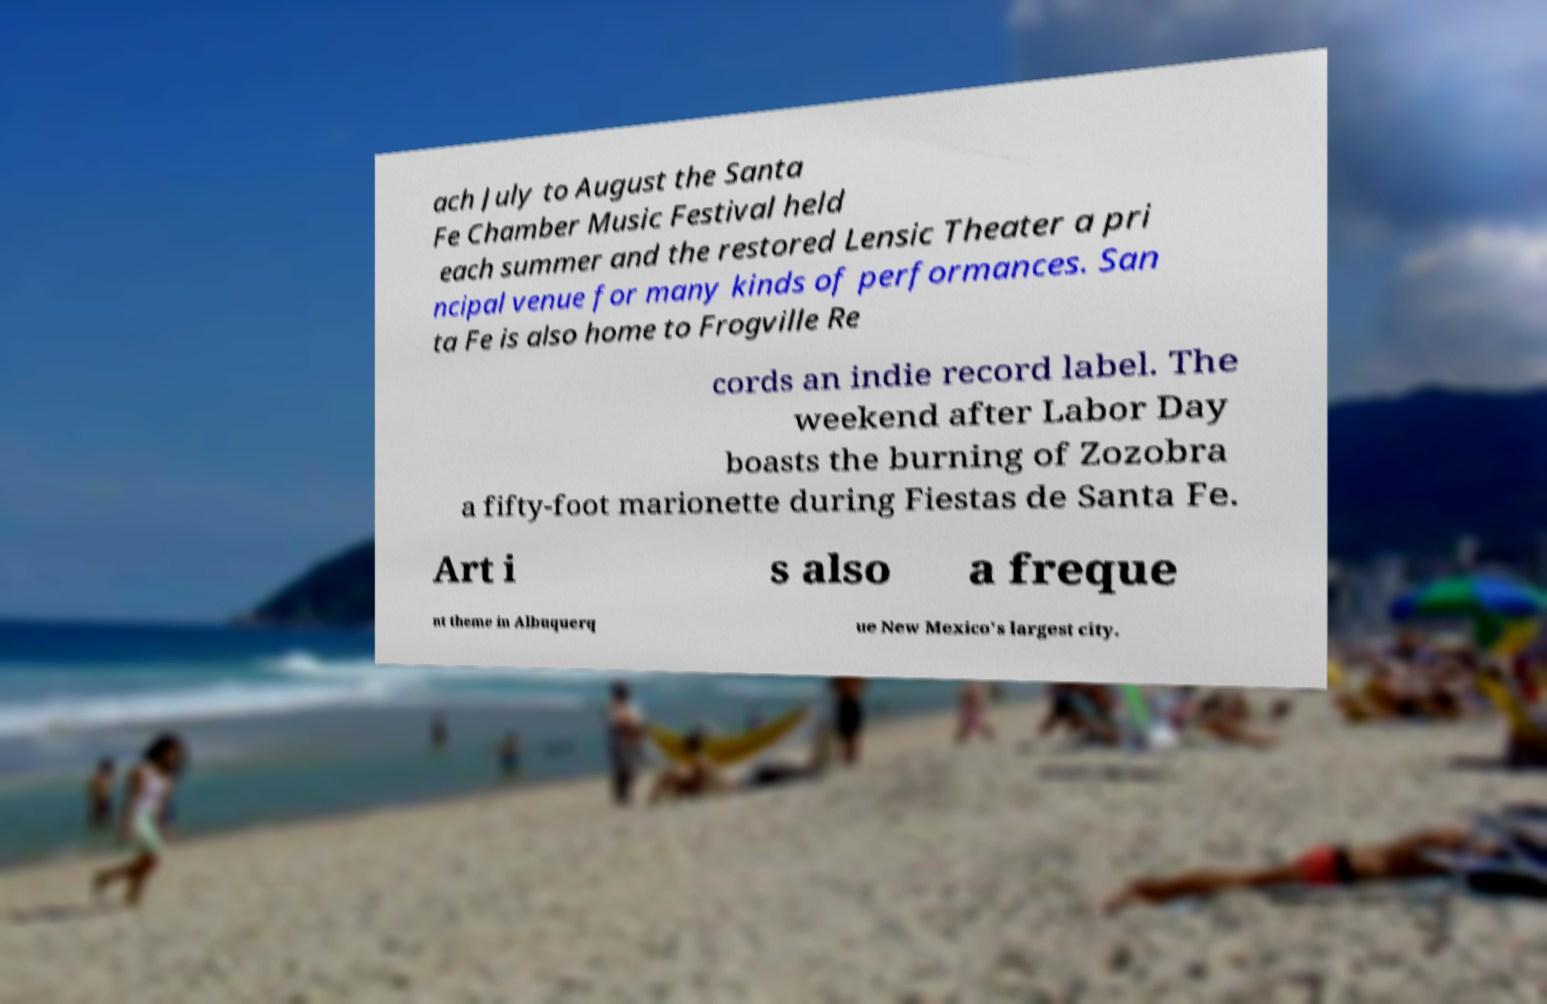Please identify and transcribe the text found in this image. ach July to August the Santa Fe Chamber Music Festival held each summer and the restored Lensic Theater a pri ncipal venue for many kinds of performances. San ta Fe is also home to Frogville Re cords an indie record label. The weekend after Labor Day boasts the burning of Zozobra a fifty-foot marionette during Fiestas de Santa Fe. Art i s also a freque nt theme in Albuquerq ue New Mexico's largest city. 